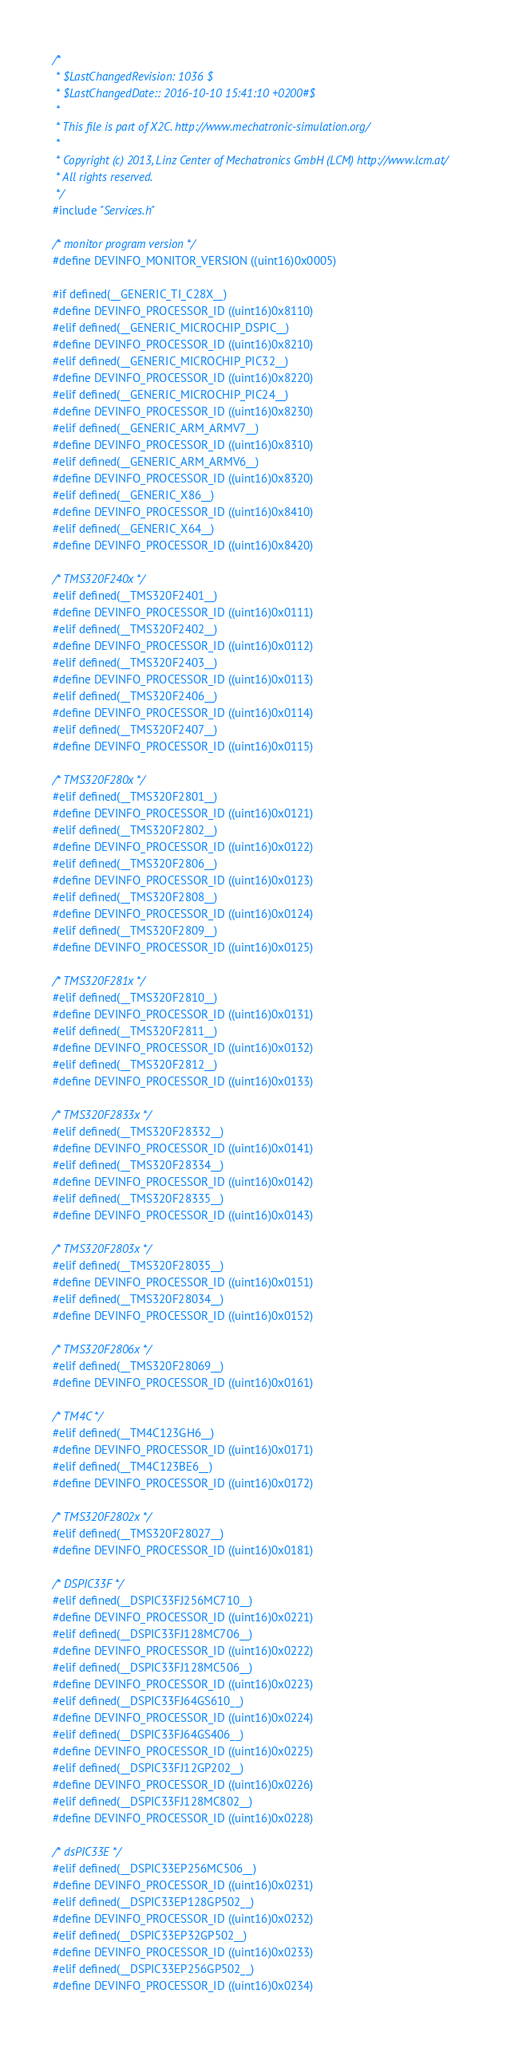<code> <loc_0><loc_0><loc_500><loc_500><_C_>/*
 * $LastChangedRevision: 1036 $
 * $LastChangedDate:: 2016-10-10 15:41:10 +0200#$
 *
 * This file is part of X2C. http://www.mechatronic-simulation.org/
 *
 * Copyright (c) 2013, Linz Center of Mechatronics GmbH (LCM) http://www.lcm.at/
 * All rights reserved.
 */
#include "Services.h"

/* monitor program version */
#define DEVINFO_MONITOR_VERSION ((uint16)0x0005)

#if defined(__GENERIC_TI_C28X__)
#define DEVINFO_PROCESSOR_ID ((uint16)0x8110)
#elif defined(__GENERIC_MICROCHIP_DSPIC__)
#define DEVINFO_PROCESSOR_ID ((uint16)0x8210)
#elif defined(__GENERIC_MICROCHIP_PIC32__)
#define DEVINFO_PROCESSOR_ID ((uint16)0x8220)
#elif defined(__GENERIC_MICROCHIP_PIC24__)
#define DEVINFO_PROCESSOR_ID ((uint16)0x8230)
#elif defined(__GENERIC_ARM_ARMV7__)
#define DEVINFO_PROCESSOR_ID ((uint16)0x8310)
#elif defined(__GENERIC_ARM_ARMV6__)
#define DEVINFO_PROCESSOR_ID ((uint16)0x8320)
#elif defined(__GENERIC_X86__)
#define DEVINFO_PROCESSOR_ID ((uint16)0x8410)
#elif defined(__GENERIC_X64__)
#define DEVINFO_PROCESSOR_ID ((uint16)0x8420)

/* TMS320F240x */
#elif defined(__TMS320F2401__)
#define DEVINFO_PROCESSOR_ID ((uint16)0x0111)
#elif defined(__TMS320F2402__)
#define DEVINFO_PROCESSOR_ID ((uint16)0x0112)
#elif defined(__TMS320F2403__)
#define DEVINFO_PROCESSOR_ID ((uint16)0x0113)
#elif defined(__TMS320F2406__)
#define DEVINFO_PROCESSOR_ID ((uint16)0x0114)
#elif defined(__TMS320F2407__)
#define DEVINFO_PROCESSOR_ID ((uint16)0x0115)

/* TMS320F280x */
#elif defined(__TMS320F2801__)
#define DEVINFO_PROCESSOR_ID ((uint16)0x0121)
#elif defined(__TMS320F2802__)
#define DEVINFO_PROCESSOR_ID ((uint16)0x0122)
#elif defined(__TMS320F2806__)
#define DEVINFO_PROCESSOR_ID ((uint16)0x0123)
#elif defined(__TMS320F2808__)
#define DEVINFO_PROCESSOR_ID ((uint16)0x0124)
#elif defined(__TMS320F2809__)
#define DEVINFO_PROCESSOR_ID ((uint16)0x0125)

/* TMS320F281x */
#elif defined(__TMS320F2810__)
#define DEVINFO_PROCESSOR_ID ((uint16)0x0131)
#elif defined(__TMS320F2811__)
#define DEVINFO_PROCESSOR_ID ((uint16)0x0132)
#elif defined(__TMS320F2812__)
#define DEVINFO_PROCESSOR_ID ((uint16)0x0133)

/* TMS320F2833x */
#elif defined(__TMS320F28332__)
#define DEVINFO_PROCESSOR_ID ((uint16)0x0141)
#elif defined(__TMS320F28334__)
#define DEVINFO_PROCESSOR_ID ((uint16)0x0142)
#elif defined(__TMS320F28335__)
#define DEVINFO_PROCESSOR_ID ((uint16)0x0143)

/* TMS320F2803x */
#elif defined(__TMS320F28035__)
#define DEVINFO_PROCESSOR_ID ((uint16)0x0151)
#elif defined(__TMS320F28034__)
#define DEVINFO_PROCESSOR_ID ((uint16)0x0152)

/* TMS320F2806x */
#elif defined(__TMS320F28069__)
#define DEVINFO_PROCESSOR_ID ((uint16)0x0161)

/* TM4C */
#elif defined(__TM4C123GH6__)
#define DEVINFO_PROCESSOR_ID ((uint16)0x0171)
#elif defined(__TM4C123BE6__)
#define DEVINFO_PROCESSOR_ID ((uint16)0x0172)

/* TMS320F2802x */
#elif defined(__TMS320F28027__)
#define DEVINFO_PROCESSOR_ID ((uint16)0x0181)

/* DSPIC33F */
#elif defined(__DSPIC33FJ256MC710__)
#define DEVINFO_PROCESSOR_ID ((uint16)0x0221)
#elif defined(__DSPIC33FJ128MC706__)
#define DEVINFO_PROCESSOR_ID ((uint16)0x0222)
#elif defined(__DSPIC33FJ128MC506__)
#define DEVINFO_PROCESSOR_ID ((uint16)0x0223)
#elif defined(__DSPIC33FJ64GS610__)
#define DEVINFO_PROCESSOR_ID ((uint16)0x0224)
#elif defined(__DSPIC33FJ64GS406__)
#define DEVINFO_PROCESSOR_ID ((uint16)0x0225)
#elif defined(__DSPIC33FJ12GP202__)
#define DEVINFO_PROCESSOR_ID ((uint16)0x0226)
#elif defined(__DSPIC33FJ128MC802__)
#define DEVINFO_PROCESSOR_ID ((uint16)0x0228)

/* dsPIC33E */
#elif defined(__DSPIC33EP256MC506__)
#define DEVINFO_PROCESSOR_ID ((uint16)0x0231)
#elif defined(__DSPIC33EP128GP502__)
#define DEVINFO_PROCESSOR_ID ((uint16)0x0232)
#elif defined(__DSPIC33EP32GP502__)
#define DEVINFO_PROCESSOR_ID ((uint16)0x0233)
#elif defined(__DSPIC33EP256GP502__)
#define DEVINFO_PROCESSOR_ID ((uint16)0x0234)</code> 